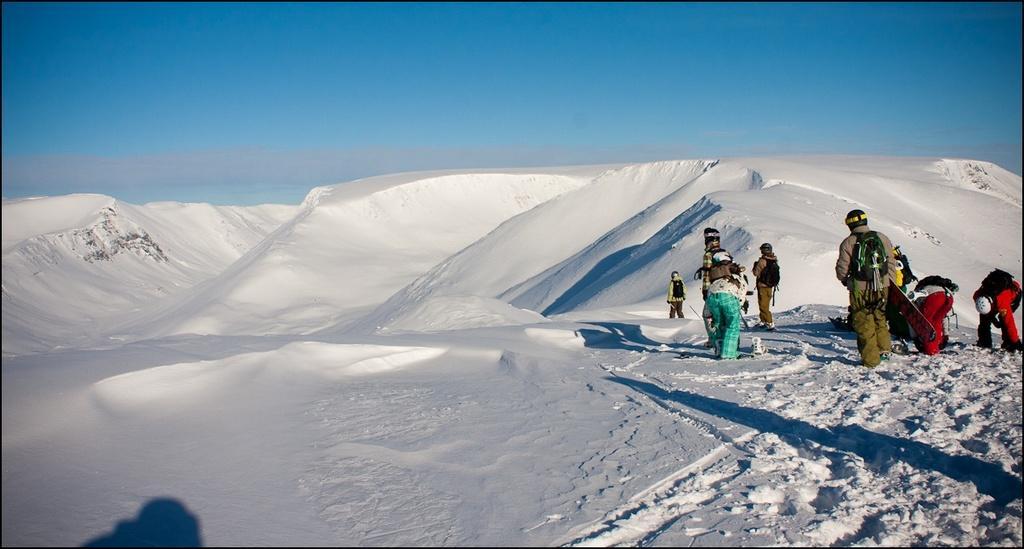Can you describe this image briefly? In this image, we can see people and some are wearing bags, helmets and holding boards in their hands. In the background, there are snow hills and at the bottom, there is snow. At the top, there is sky. 